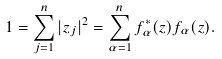<formula> <loc_0><loc_0><loc_500><loc_500>1 = \sum _ { j = 1 } ^ { n } | z _ { j } | ^ { 2 } = \sum _ { \alpha = 1 } ^ { n } f _ { \alpha } ^ { * } ( z ) f _ { \alpha } ( z ) .</formula> 